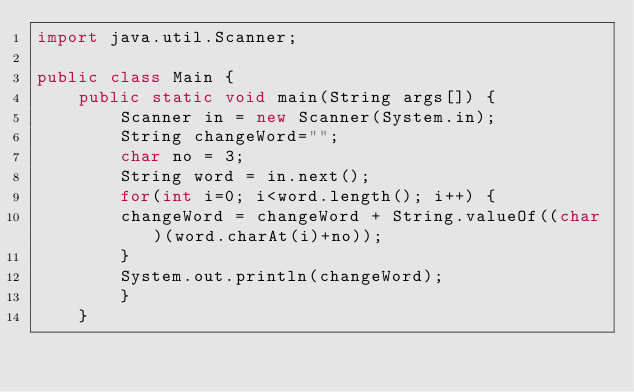Convert code to text. <code><loc_0><loc_0><loc_500><loc_500><_Java_>import java.util.Scanner;

public class Main {
	public static void main(String args[]) {
		Scanner in = new Scanner(System.in);
		String changeWord="";
		char no = 3;
		String word = in.next();
		for(int i=0; i<word.length(); i++) {
		changeWord = changeWord + String.valueOf((char)(word.charAt(i)+no));
		}
		System.out.println(changeWord);
		}
	}</code> 